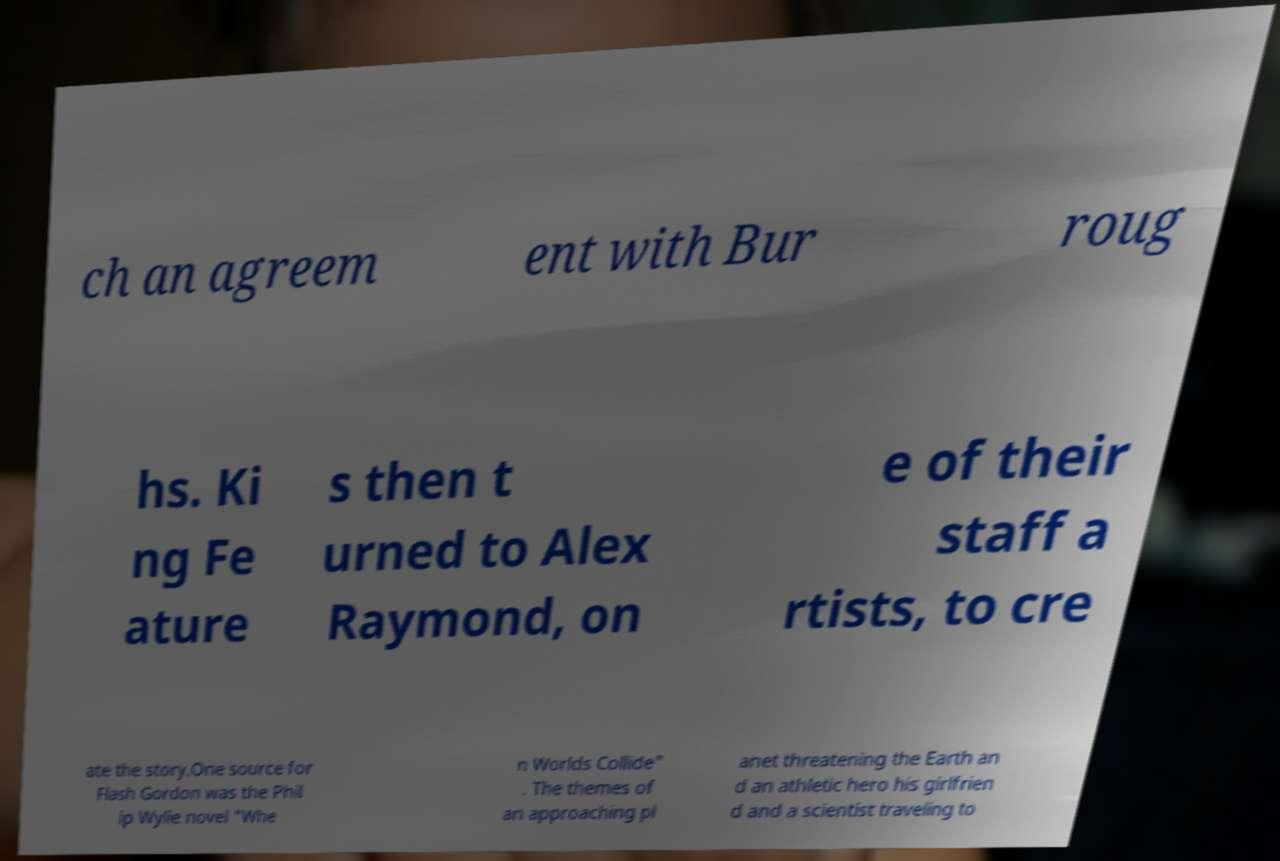I need the written content from this picture converted into text. Can you do that? ch an agreem ent with Bur roug hs. Ki ng Fe ature s then t urned to Alex Raymond, on e of their staff a rtists, to cre ate the story.One source for Flash Gordon was the Phil ip Wylie novel "Whe n Worlds Collide" . The themes of an approaching pl anet threatening the Earth an d an athletic hero his girlfrien d and a scientist traveling to 